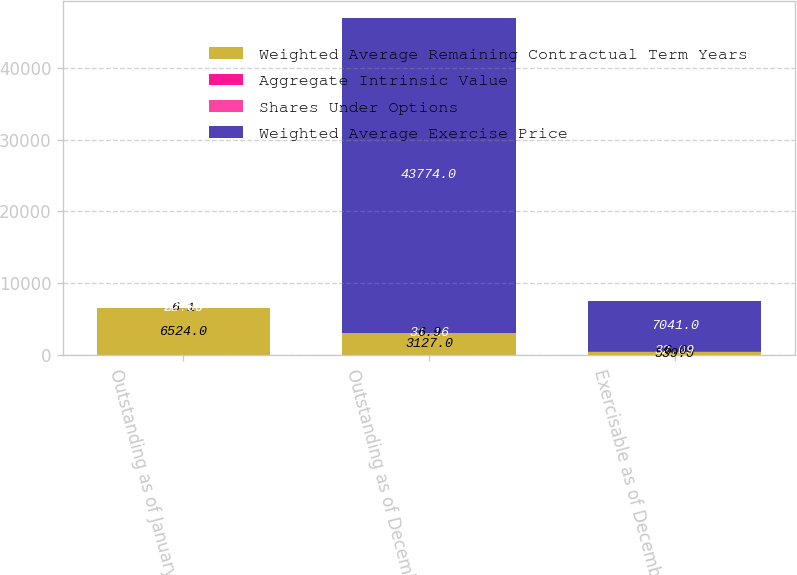<chart> <loc_0><loc_0><loc_500><loc_500><stacked_bar_chart><ecel><fcel>Outstanding as of January 1<fcel>Outstanding as of December 31<fcel>Exercisable as of December 31<nl><fcel>Weighted Average Remaining Contractual Term Years<fcel>6524<fcel>3127<fcel>539<nl><fcel>Aggregate Intrinsic Value<fcel>28.76<fcel>31.16<fcel>32.09<nl><fcel>Shares Under Options<fcel>6.1<fcel>6.9<fcel>6<nl><fcel>Weighted Average Exercise Price<fcel>32.09<fcel>43774<fcel>7041<nl></chart> 